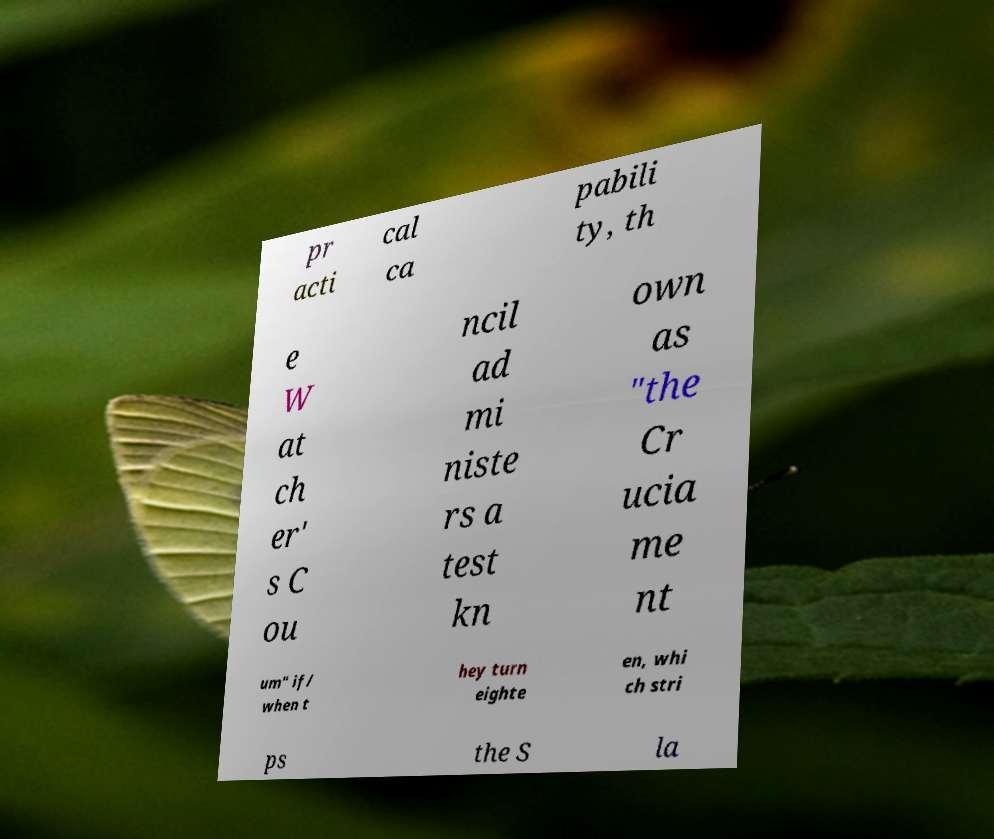What messages or text are displayed in this image? I need them in a readable, typed format. pr acti cal ca pabili ty, th e W at ch er' s C ou ncil ad mi niste rs a test kn own as "the Cr ucia me nt um" if/ when t hey turn eighte en, whi ch stri ps the S la 